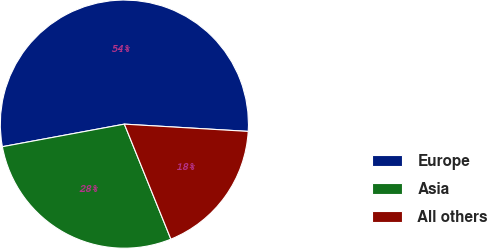<chart> <loc_0><loc_0><loc_500><loc_500><pie_chart><fcel>Europe<fcel>Asia<fcel>All others<nl><fcel>53.85%<fcel>28.21%<fcel>17.95%<nl></chart> 